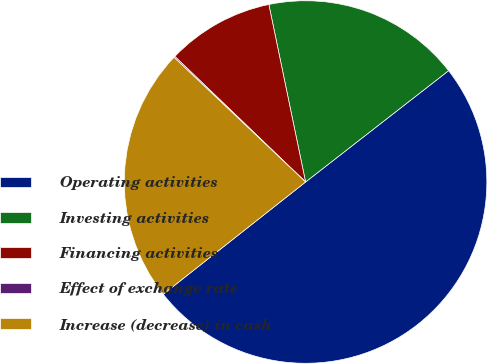Convert chart to OTSL. <chart><loc_0><loc_0><loc_500><loc_500><pie_chart><fcel>Operating activities<fcel>Investing activities<fcel>Financing activities<fcel>Effect of exchange rate<fcel>Increase (decrease) in cash<nl><fcel>49.9%<fcel>17.72%<fcel>9.57%<fcel>0.11%<fcel>22.7%<nl></chart> 